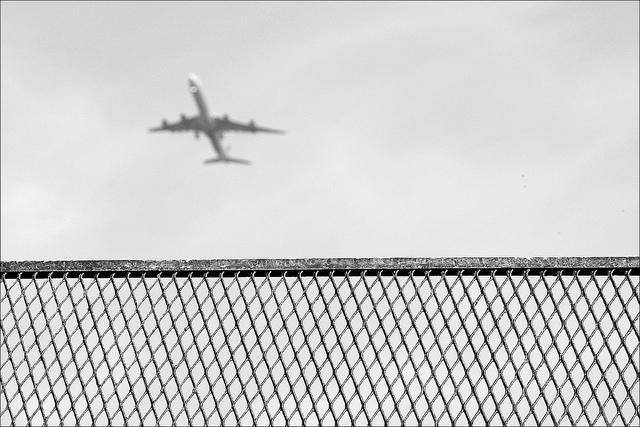How many wood chairs are tilted?
Give a very brief answer. 0. 